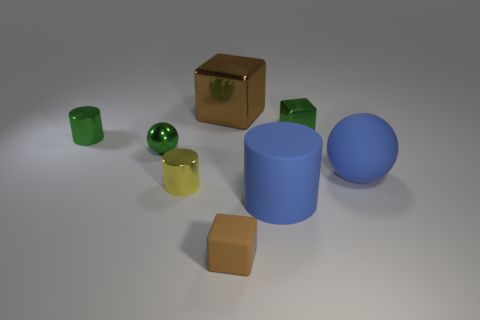The block that is both left of the blue matte cylinder and behind the yellow metal cylinder is what color?
Provide a short and direct response. Brown. Is there a small block of the same color as the shiny ball?
Offer a terse response. Yes. Does the large object that is behind the metal ball have the same material as the big blue object behind the large cylinder?
Make the answer very short. No. There is a cylinder behind the yellow metallic object; what is its size?
Provide a succinct answer. Small. The blue cylinder is what size?
Your answer should be very brief. Large. There is a ball right of the brown cube that is behind the small green metal object left of the green metallic sphere; what is its size?
Keep it short and to the point. Large. Is there a blue object made of the same material as the yellow cylinder?
Offer a terse response. No. What shape is the big brown thing?
Provide a succinct answer. Cube. What is the color of the big thing that is made of the same material as the blue cylinder?
Provide a short and direct response. Blue. How many cyan objects are metal cylinders or small matte blocks?
Offer a very short reply. 0. 